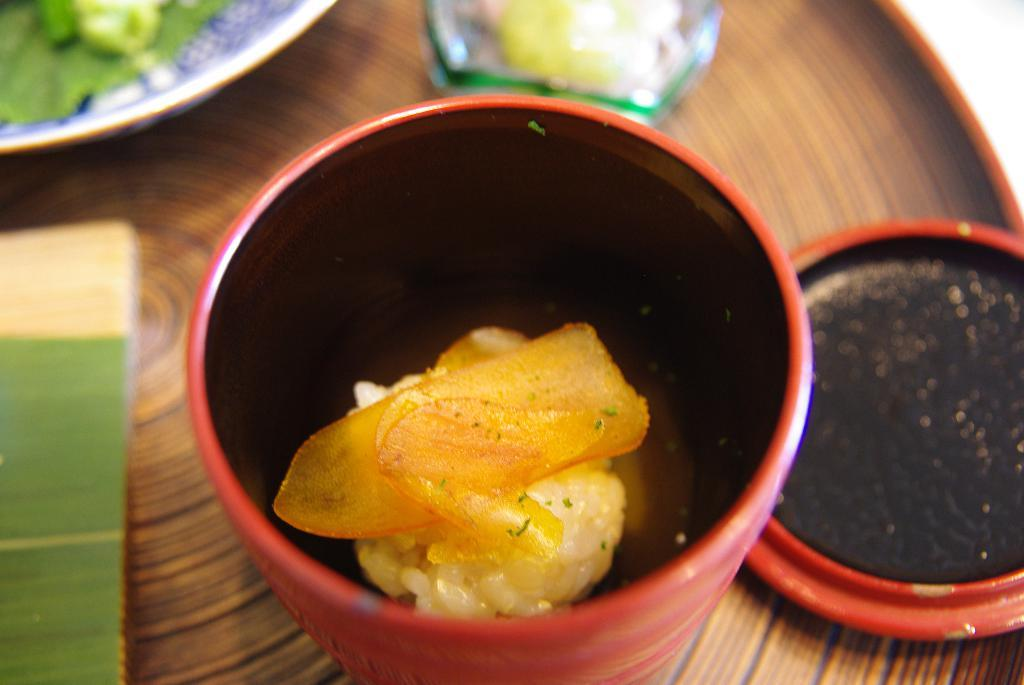What objects are on the table in the image? There are bowls on a table in the image. What is inside the bowls? The bowls contain food. What type of bear can be seen sitting next to the bowls in the image? There is no bear present in the image; it only features bowls containing food. What kind of plants are growing around the table in the image? There is no information about plants in the image; it only shows bowls containing food on a table. 